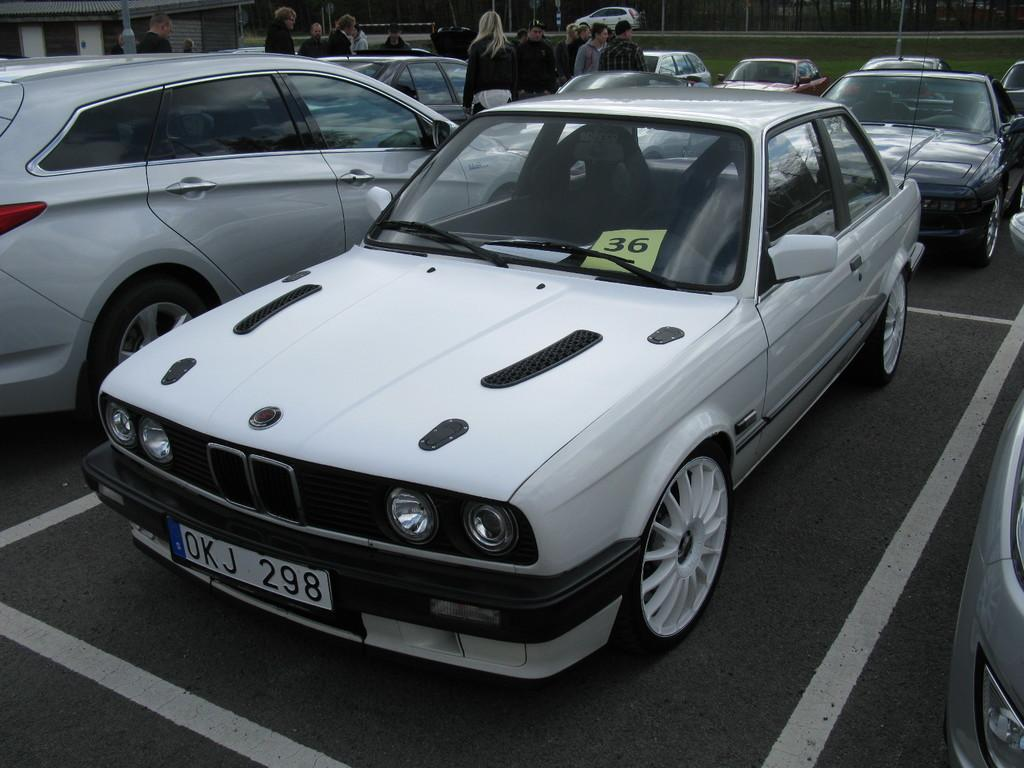What types of objects are present in the image? There are vehicles and people in the image. What structure can be seen in the image? There is a building in the image. What else is visible in the background of the image? There are poles visible in the background of the image. Can you tell me how many mothers are talking in the alley in the image? There is no alley or mother present in the image. What type of creature is shown interacting with the vehicles in the image? There are no creatures shown interacting with the vehicles in the image; only people and vehicles are present. 